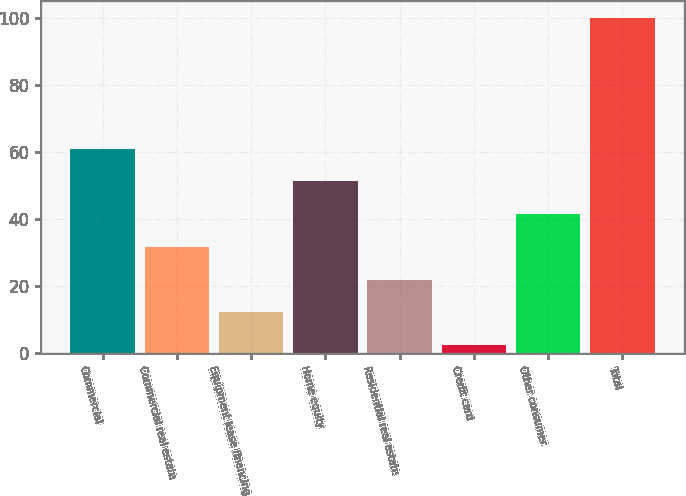Convert chart. <chart><loc_0><loc_0><loc_500><loc_500><bar_chart><fcel>Commercial<fcel>Commercial real estate<fcel>Equipment lease financing<fcel>Home equity<fcel>Residential real estate<fcel>Credit card<fcel>Other consumer<fcel>Total<nl><fcel>60.92<fcel>31.61<fcel>12.07<fcel>51.15<fcel>21.84<fcel>2.3<fcel>41.38<fcel>100<nl></chart> 